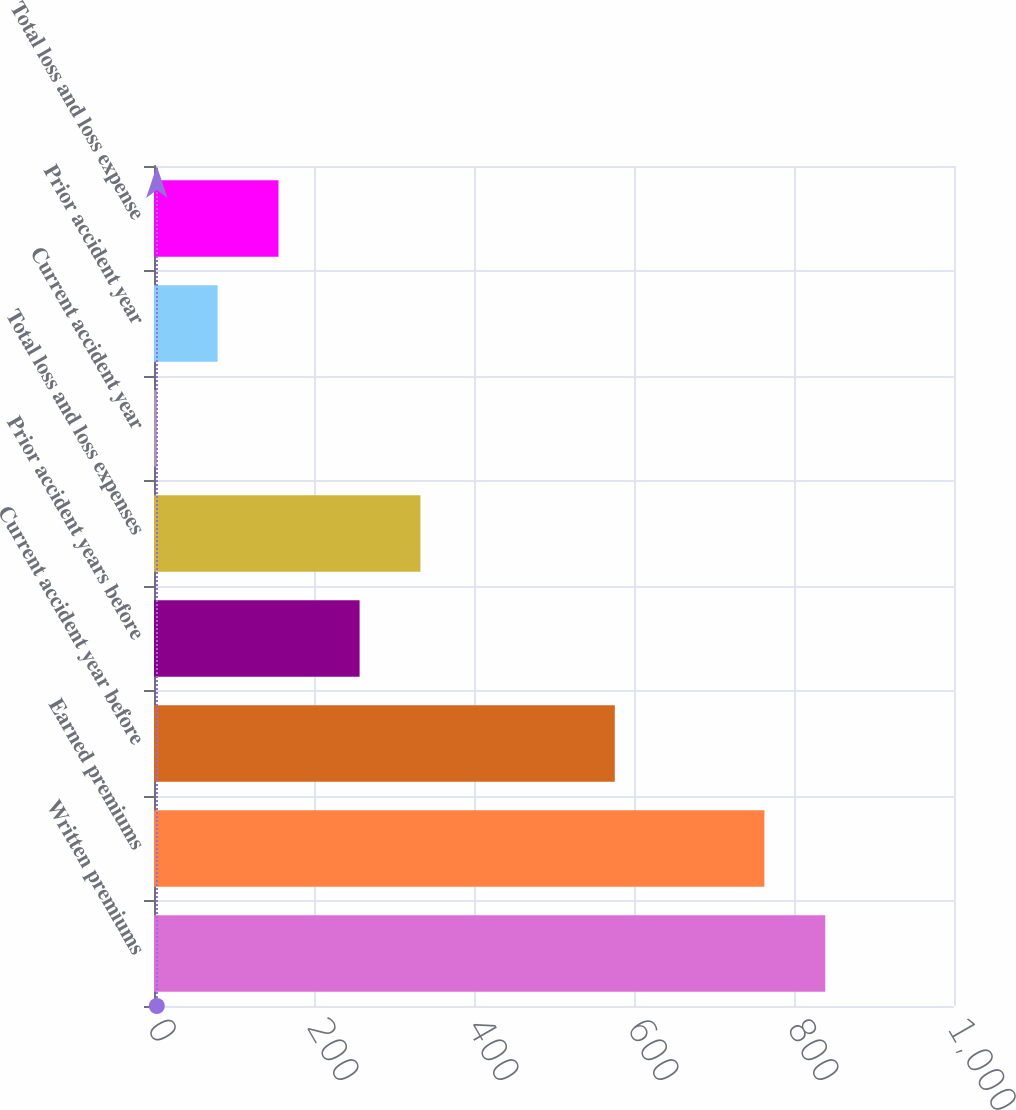Convert chart to OTSL. <chart><loc_0><loc_0><loc_500><loc_500><bar_chart><fcel>Written premiums<fcel>Earned premiums<fcel>Current accident year before<fcel>Prior accident years before<fcel>Total loss and loss expenses<fcel>Current accident year<fcel>Prior accident year<fcel>Total loss and loss expense<nl><fcel>839.05<fcel>763<fcel>576<fcel>257<fcel>333.05<fcel>3.52<fcel>79.57<fcel>155.62<nl></chart> 